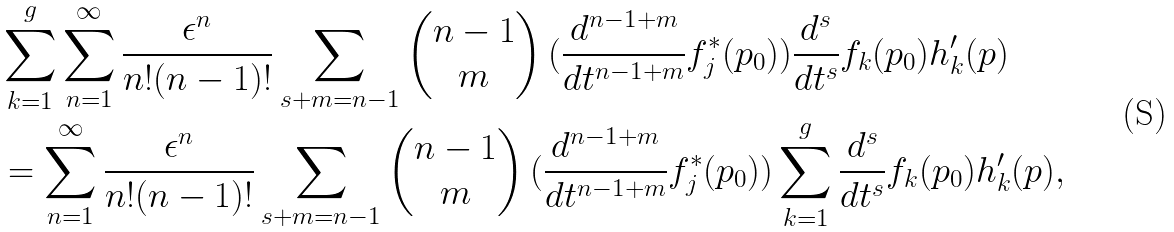Convert formula to latex. <formula><loc_0><loc_0><loc_500><loc_500>& \sum _ { k = 1 } ^ { g } \sum _ { n = 1 } ^ { \infty } \frac { \epsilon ^ { n } } { n ! ( n - 1 ) ! } \sum _ { s + m = n - 1 } \begin{pmatrix} n - 1 \\ m \end{pmatrix} ( \frac { d ^ { n - 1 + m } } { d t ^ { n - 1 + m } } f ^ { \ast } _ { j } ( p _ { 0 } ) ) \frac { d ^ { s } } { d t ^ { s } } f _ { k } ( p _ { 0 } ) h ^ { \prime } _ { k } ( p ) \\ & = \sum _ { n = 1 } ^ { \infty } \frac { \epsilon ^ { n } } { n ! ( n - 1 ) ! } \sum _ { s + m = n - 1 } \begin{pmatrix} n - 1 \\ m \end{pmatrix} ( \frac { d ^ { n - 1 + m } } { d t ^ { n - 1 + m } } f ^ { \ast } _ { j } ( p _ { 0 } ) ) \sum _ { k = 1 } ^ { g } \frac { d ^ { s } } { d t ^ { s } } f _ { k } ( p _ { 0 } ) h ^ { \prime } _ { k } ( p ) ,</formula> 